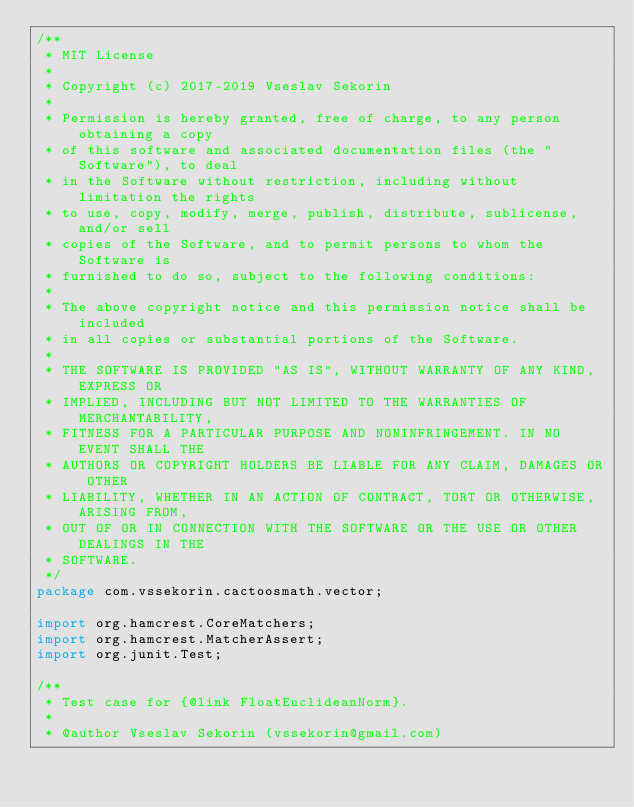Convert code to text. <code><loc_0><loc_0><loc_500><loc_500><_Java_>/**
 * MIT License
 *
 * Copyright (c) 2017-2019 Vseslav Sekorin
 *
 * Permission is hereby granted, free of charge, to any person obtaining a copy
 * of this software and associated documentation files (the "Software"), to deal
 * in the Software without restriction, including without limitation the rights
 * to use, copy, modify, merge, publish, distribute, sublicense, and/or sell
 * copies of the Software, and to permit persons to whom the Software is
 * furnished to do so, subject to the following conditions:
 *
 * The above copyright notice and this permission notice shall be included
 * in all copies or substantial portions of the Software.
 *
 * THE SOFTWARE IS PROVIDED "AS IS", WITHOUT WARRANTY OF ANY KIND, EXPRESS OR
 * IMPLIED, INCLUDING BUT NOT LIMITED TO THE WARRANTIES OF MERCHANTABILITY,
 * FITNESS FOR A PARTICULAR PURPOSE AND NONINFRINGEMENT. IN NO EVENT SHALL THE
 * AUTHORS OR COPYRIGHT HOLDERS BE LIABLE FOR ANY CLAIM, DAMAGES OR OTHER
 * LIABILITY, WHETHER IN AN ACTION OF CONTRACT, TORT OR OTHERWISE, ARISING FROM,
 * OUT OF OR IN CONNECTION WITH THE SOFTWARE OR THE USE OR OTHER DEALINGS IN THE
 * SOFTWARE.
 */
package com.vssekorin.cactoosmath.vector;

import org.hamcrest.CoreMatchers;
import org.hamcrest.MatcherAssert;
import org.junit.Test;

/**
 * Test case for {@link FloatEuclideanNorm}.
 *
 * @author Vseslav Sekorin (vssekorin@gmail.com)</code> 